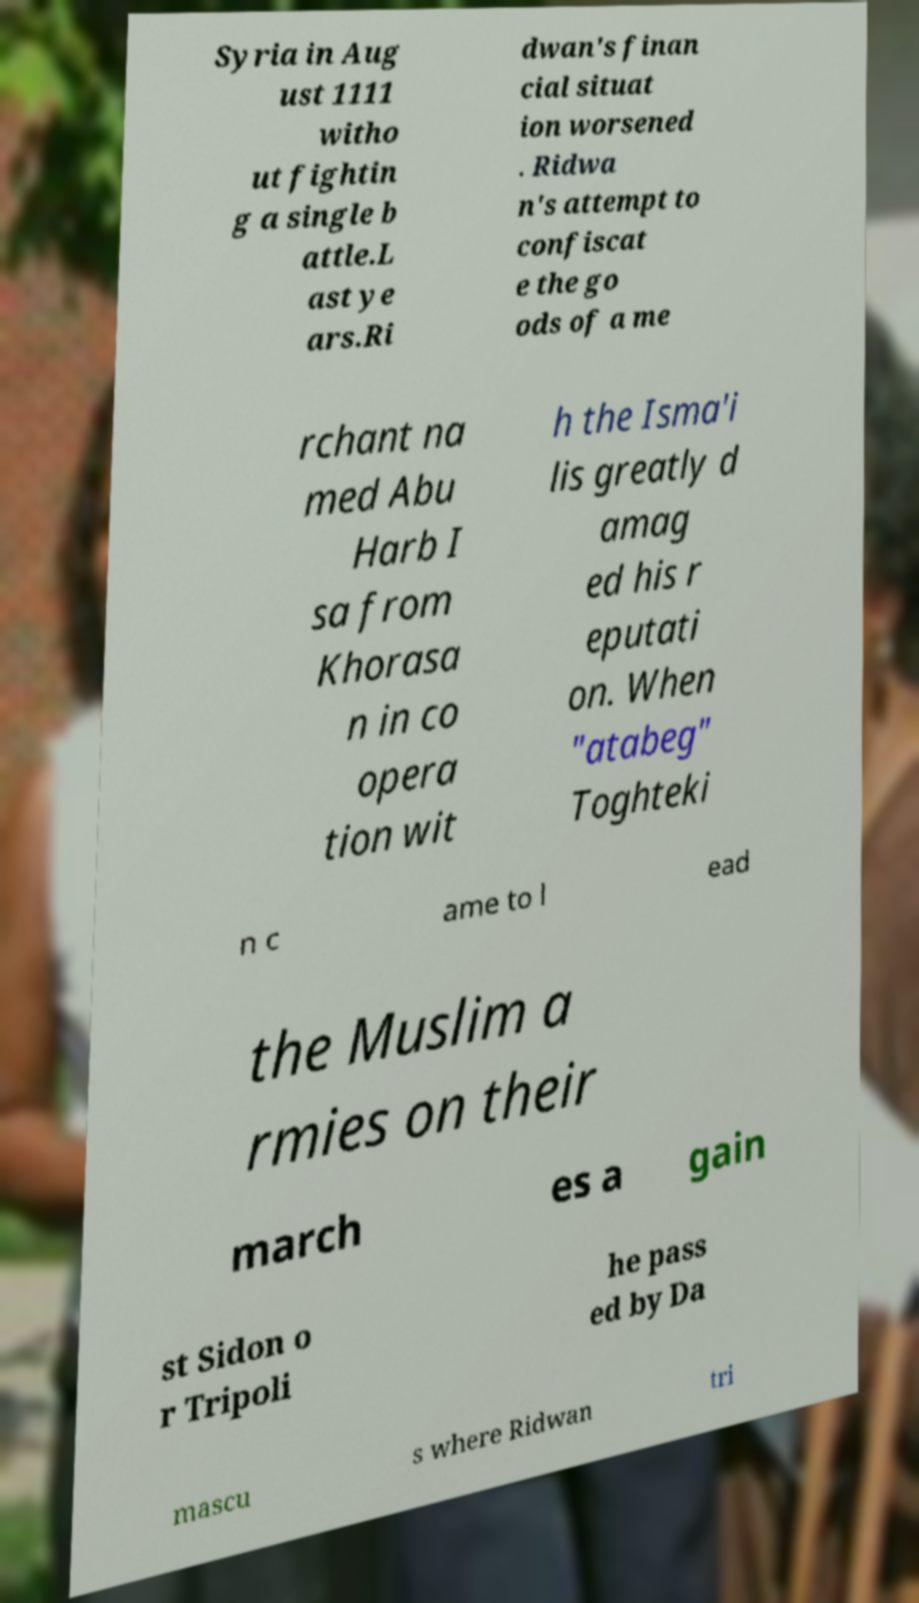There's text embedded in this image that I need extracted. Can you transcribe it verbatim? Syria in Aug ust 1111 witho ut fightin g a single b attle.L ast ye ars.Ri dwan's finan cial situat ion worsened . Ridwa n's attempt to confiscat e the go ods of a me rchant na med Abu Harb I sa from Khorasa n in co opera tion wit h the Isma'i lis greatly d amag ed his r eputati on. When "atabeg" Toghteki n c ame to l ead the Muslim a rmies on their march es a gain st Sidon o r Tripoli he pass ed by Da mascu s where Ridwan tri 